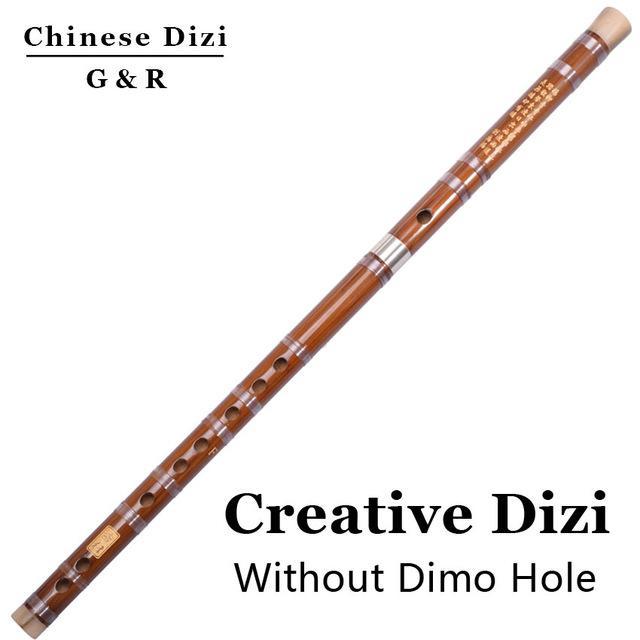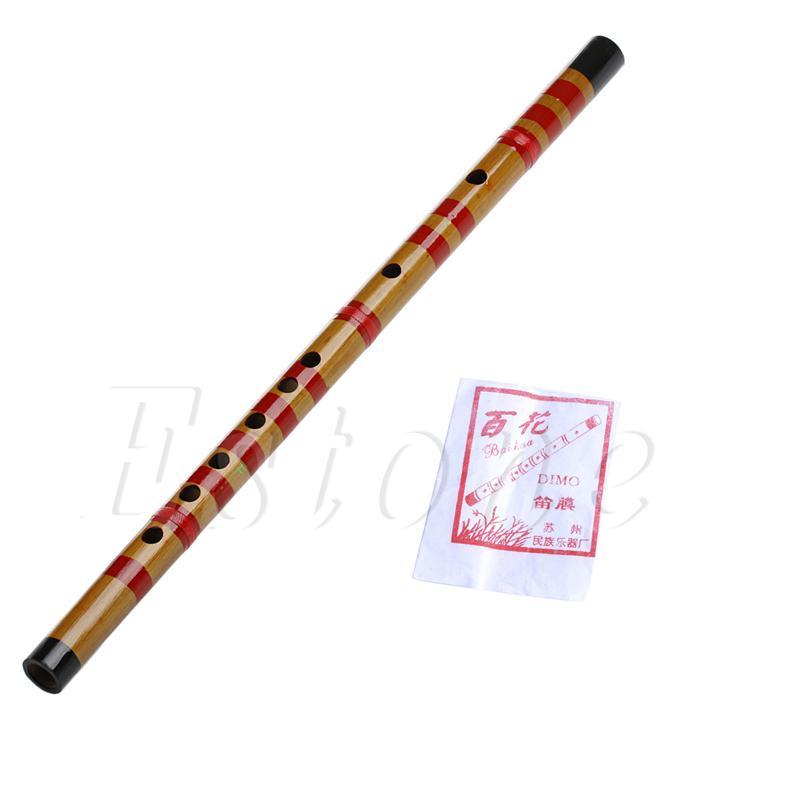The first image is the image on the left, the second image is the image on the right. Evaluate the accuracy of this statement regarding the images: "There are exactly two flutes.". Is it true? Answer yes or no. Yes. The first image is the image on the left, the second image is the image on the right. Assess this claim about the two images: "Each image features one bamboo flute displayed diagonally so one end is on the upper right.". Correct or not? Answer yes or no. Yes. 